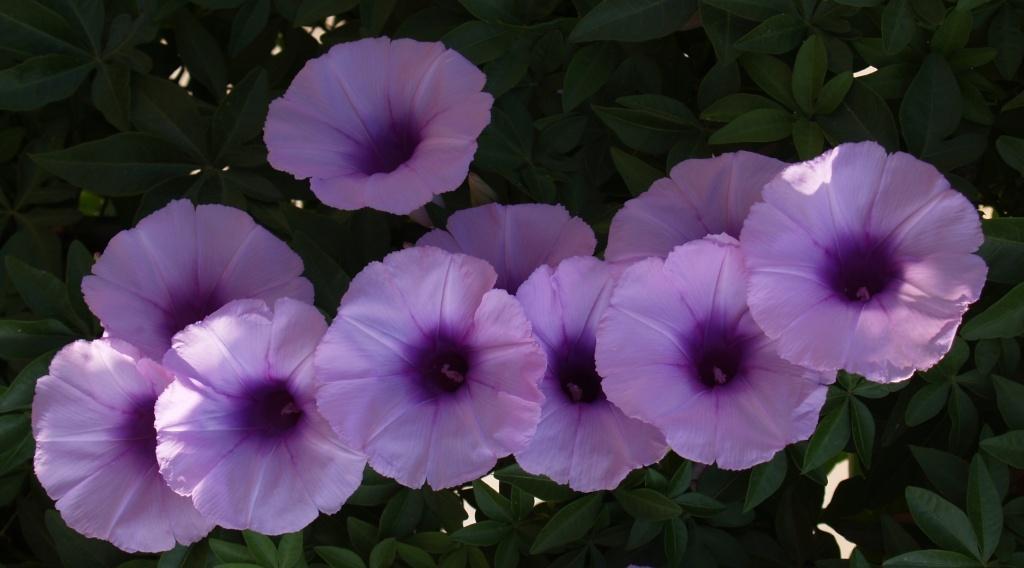Could you give a brief overview of what you see in this image? Here we can see a plant with flowers. 